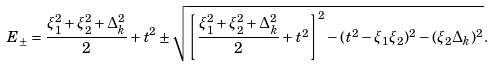Convert formula to latex. <formula><loc_0><loc_0><loc_500><loc_500>E _ { \pm } = \frac { \xi _ { 1 } ^ { 2 } + \xi _ { 2 } ^ { 2 } + \Delta _ { k } ^ { 2 } } { 2 } + t ^ { 2 } \pm \sqrt { \left [ \frac { \xi _ { 1 } ^ { 2 } + \xi _ { 2 } ^ { 2 } + \Delta _ { k } ^ { 2 } } { 2 } + t ^ { 2 } \right ] ^ { 2 } - ( t ^ { 2 } - \xi _ { 1 } \xi _ { 2 } ) ^ { 2 } - ( \xi _ { 2 } \Delta _ { k } ) ^ { 2 } } .</formula> 